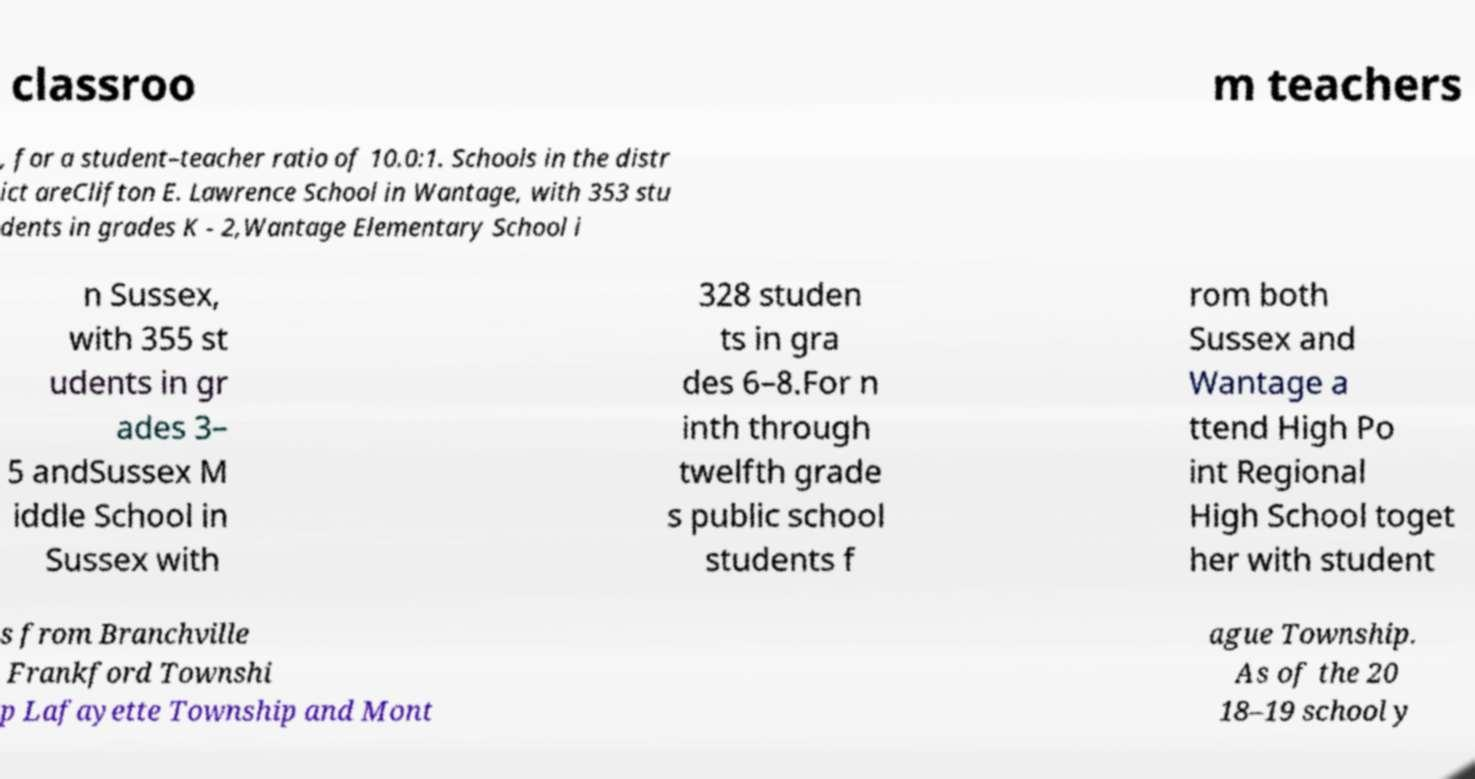Could you assist in decoding the text presented in this image and type it out clearly? classroo m teachers , for a student–teacher ratio of 10.0:1. Schools in the distr ict areClifton E. Lawrence School in Wantage, with 353 stu dents in grades K - 2,Wantage Elementary School i n Sussex, with 355 st udents in gr ades 3– 5 andSussex M iddle School in Sussex with 328 studen ts in gra des 6–8.For n inth through twelfth grade s public school students f rom both Sussex and Wantage a ttend High Po int Regional High School toget her with student s from Branchville Frankford Townshi p Lafayette Township and Mont ague Township. As of the 20 18–19 school y 